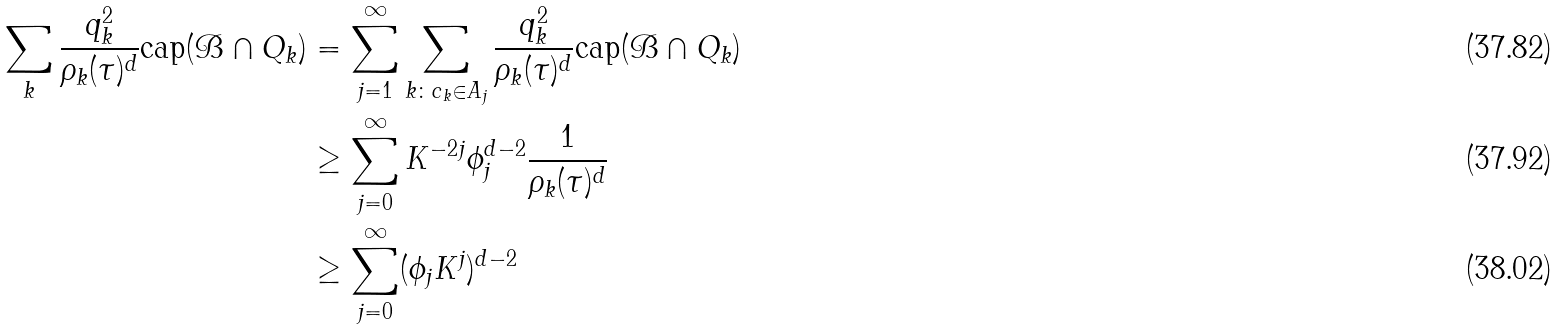Convert formula to latex. <formula><loc_0><loc_0><loc_500><loc_500>\sum _ { k } \frac { q _ { k } ^ { 2 } } { \rho _ { k } ( \tau ) ^ { d } } \text {cap} ( \mathcal { B } \cap Q _ { k } ) & = \sum _ { j = 1 } ^ { \infty } \sum _ { k \colon c _ { k } \in A _ { j } } \frac { q _ { k } ^ { 2 } } { \rho _ { k } ( \tau ) ^ { d } } \text {cap} ( \mathcal { B } \cap Q _ { k } ) \\ & \geq \sum _ { j = 0 } ^ { \infty } K ^ { - 2 j } \phi _ { j } ^ { d - 2 } \frac { 1 } { \rho _ { k } ( \tau ) ^ { d } } \\ & \geq \sum _ { j = 0 } ^ { \infty } ( \phi _ { j } K ^ { j } ) ^ { d - 2 }</formula> 